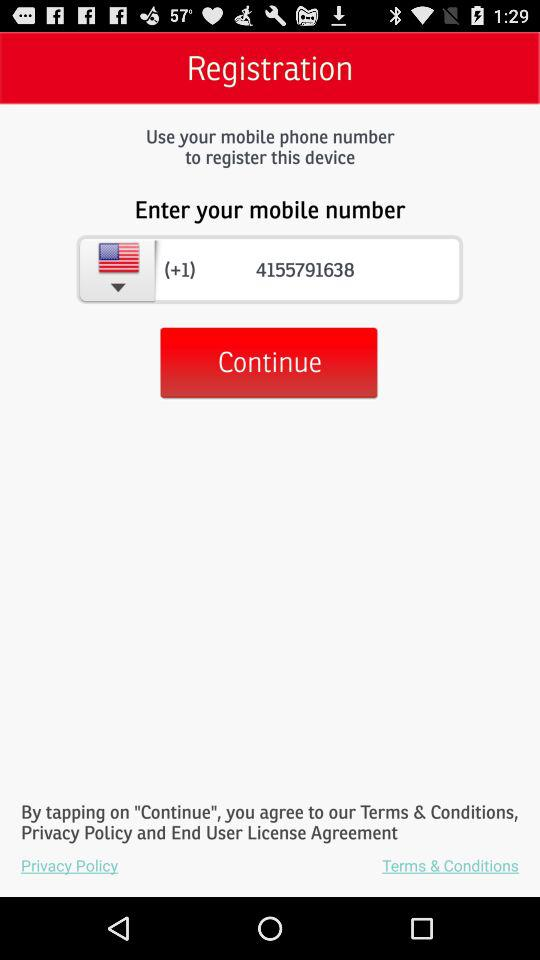What is the mobile number? The mobile number is (+1) 4155791638. 